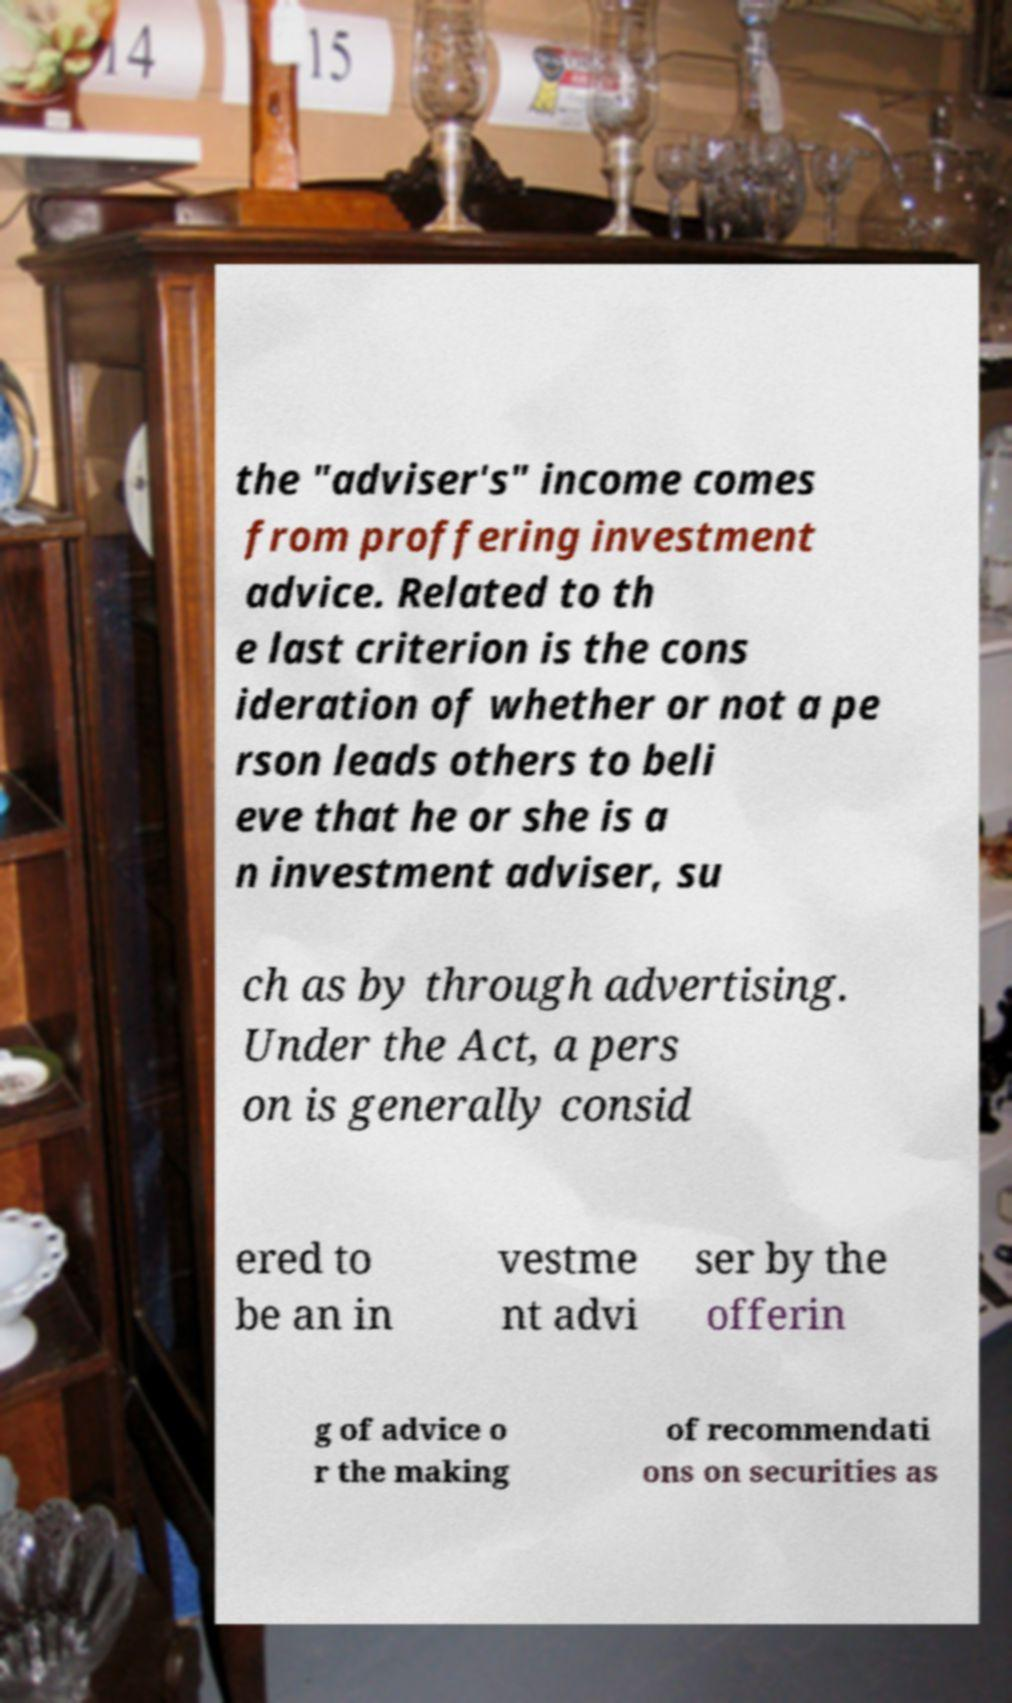Can you accurately transcribe the text from the provided image for me? the "adviser's" income comes from proffering investment advice. Related to th e last criterion is the cons ideration of whether or not a pe rson leads others to beli eve that he or she is a n investment adviser, su ch as by through advertising. Under the Act, a pers on is generally consid ered to be an in vestme nt advi ser by the offerin g of advice o r the making of recommendati ons on securities as 